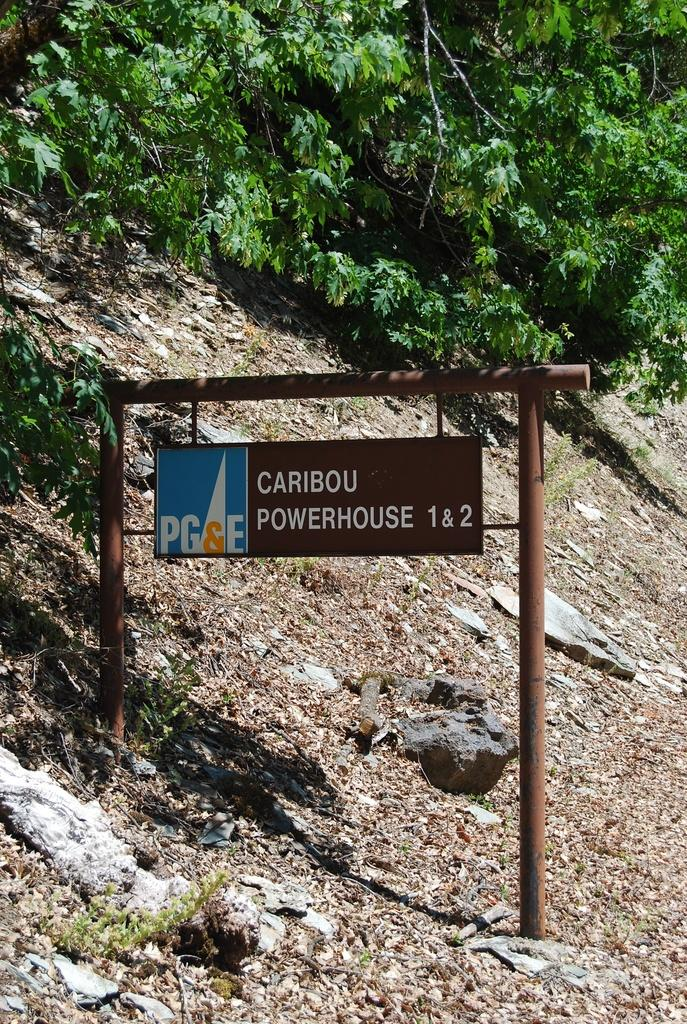What type of natural elements can be seen in the image? There are trees in the image. What man-made object is present in the image? There is a sign board in the image. What type of flesh can be seen on the trees in the image? There is no flesh present on the trees in the image; they are made of wood and leaves. What type of arch is visible in the image? There is no arch present in the image; it only features trees and a sign board. 